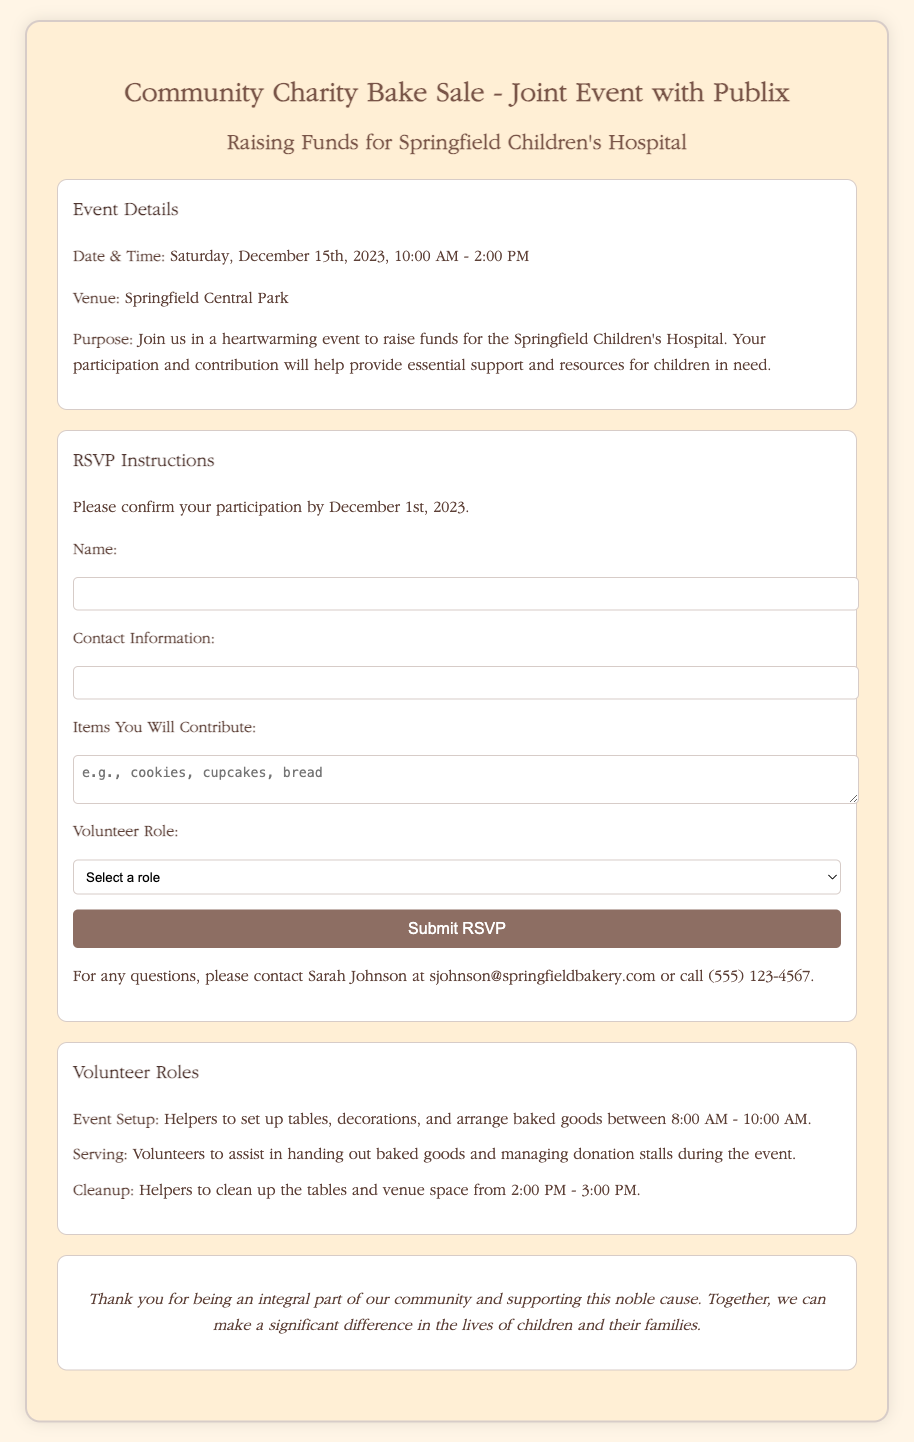What is the date of the bake sale? The date of the bake sale is mentioned in the event details of the document.
Answer: Saturday, December 15th, 2023 What time does the event start? The event starting time is indicated in the event details section of the document.
Answer: 10:00 AM What is the venue for the bake sale? The venue for the bake sale is specified in the event details section.
Answer: Springfield Central Park What items can participants contribute? The document provides examples of items that can be contributed in the RSVP form.
Answer: cookies, cupcakes, bread Who should participants contact for questions? The contact person for questions is listed towards the end of the RSVP instructions.
Answer: Sarah Johnson How many volunteer roles are listed? The number of volunteer roles can be counted from the volunteer roles section of the document.
Answer: Three What time is the setup for the event scheduled? The setup time for volunteers is mentioned in the description of the Event Setup role.
Answer: 8:00 AM - 10:00 AM When is the RSVP deadline? The RSVP deadline is indicated in the RSVP instructions.
Answer: December 1st, 2023 What is the main purpose of the bake sale? The main purpose is clearly stated in the purpose section of the event details.
Answer: Raise funds for Springfield Children's Hospital 